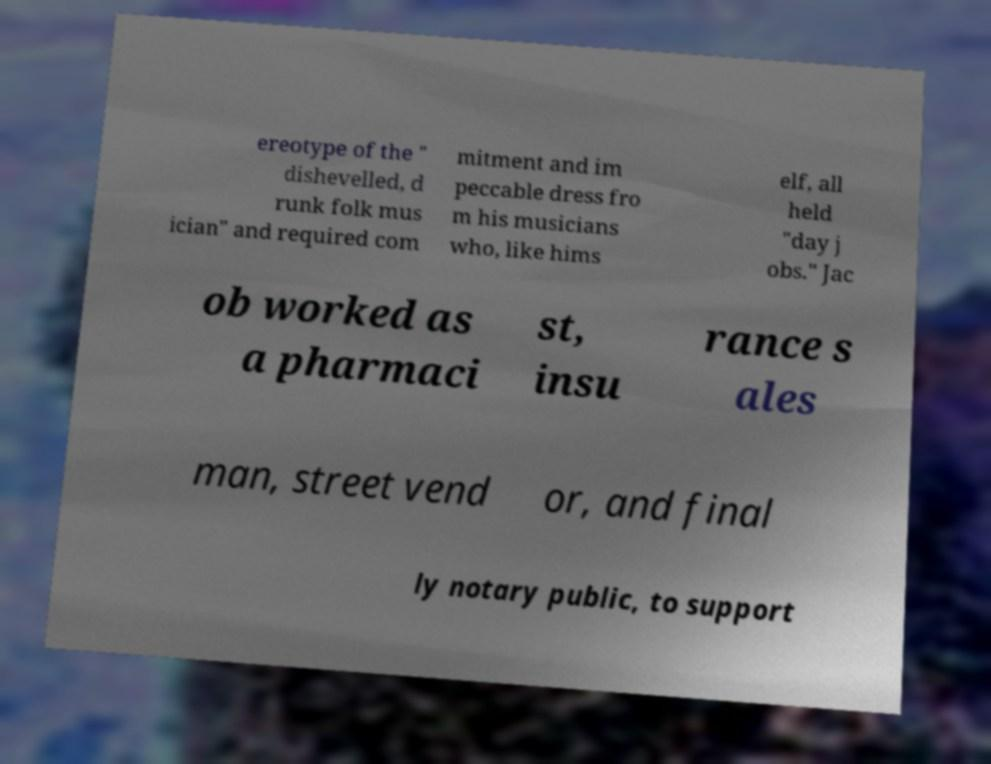Can you read and provide the text displayed in the image?This photo seems to have some interesting text. Can you extract and type it out for me? ereotype of the " dishevelled, d runk folk mus ician" and required com mitment and im peccable dress fro m his musicians who, like hims elf, all held "day j obs." Jac ob worked as a pharmaci st, insu rance s ales man, street vend or, and final ly notary public, to support 